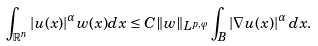Convert formula to latex. <formula><loc_0><loc_0><loc_500><loc_500>\int _ { \mathbb { R } ^ { n } } | u ( x ) | ^ { \alpha } w ( x ) d x & \leq C \| w \| _ { L ^ { p , \varphi } } \int _ { B } | \nabla u ( x ) | ^ { \alpha } \, d x .</formula> 